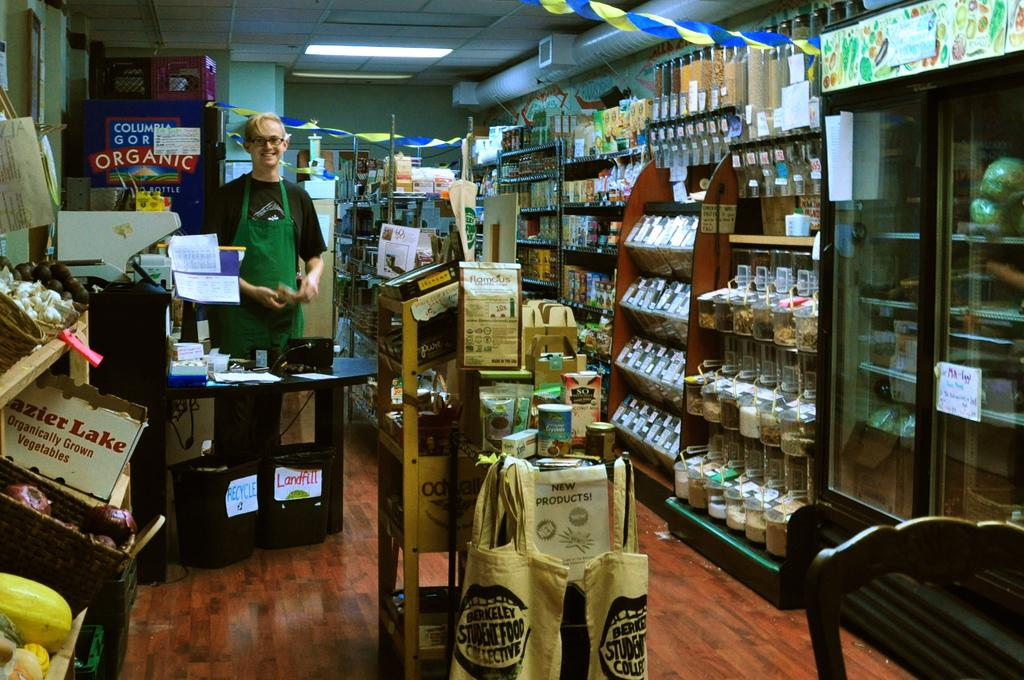<image>
Describe the image concisely. inside the general store with Berkeley student food bags hanging 